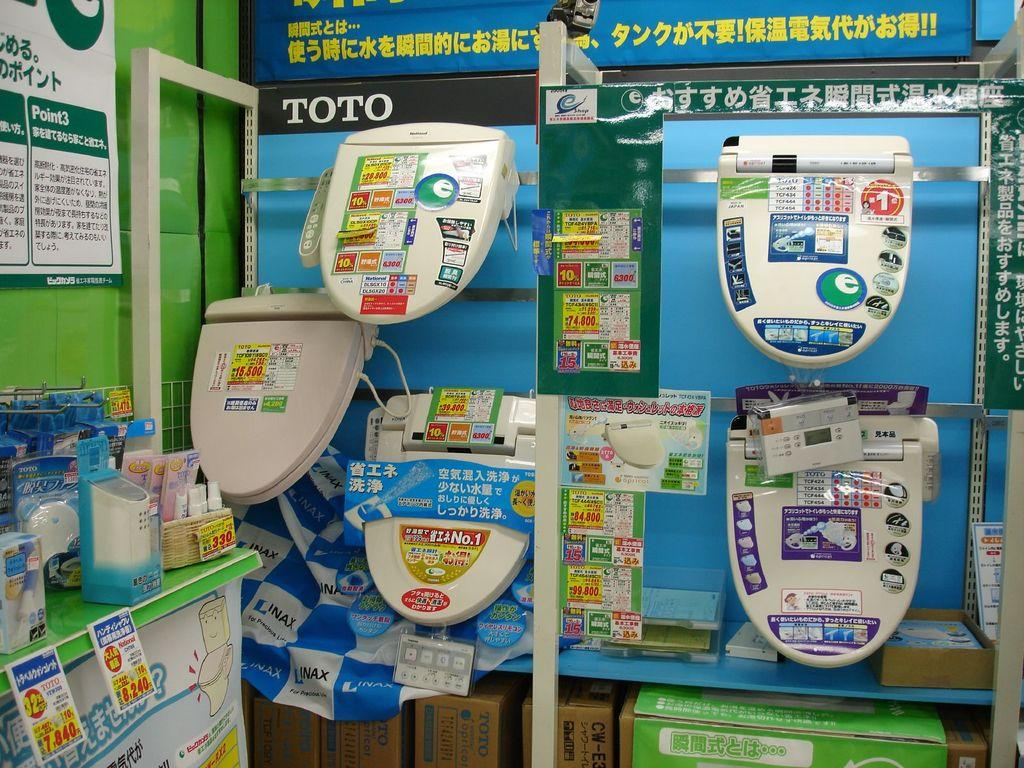<image>
Give a short and clear explanation of the subsequent image. Display of product in chinese language and titled TOTO on the top left 